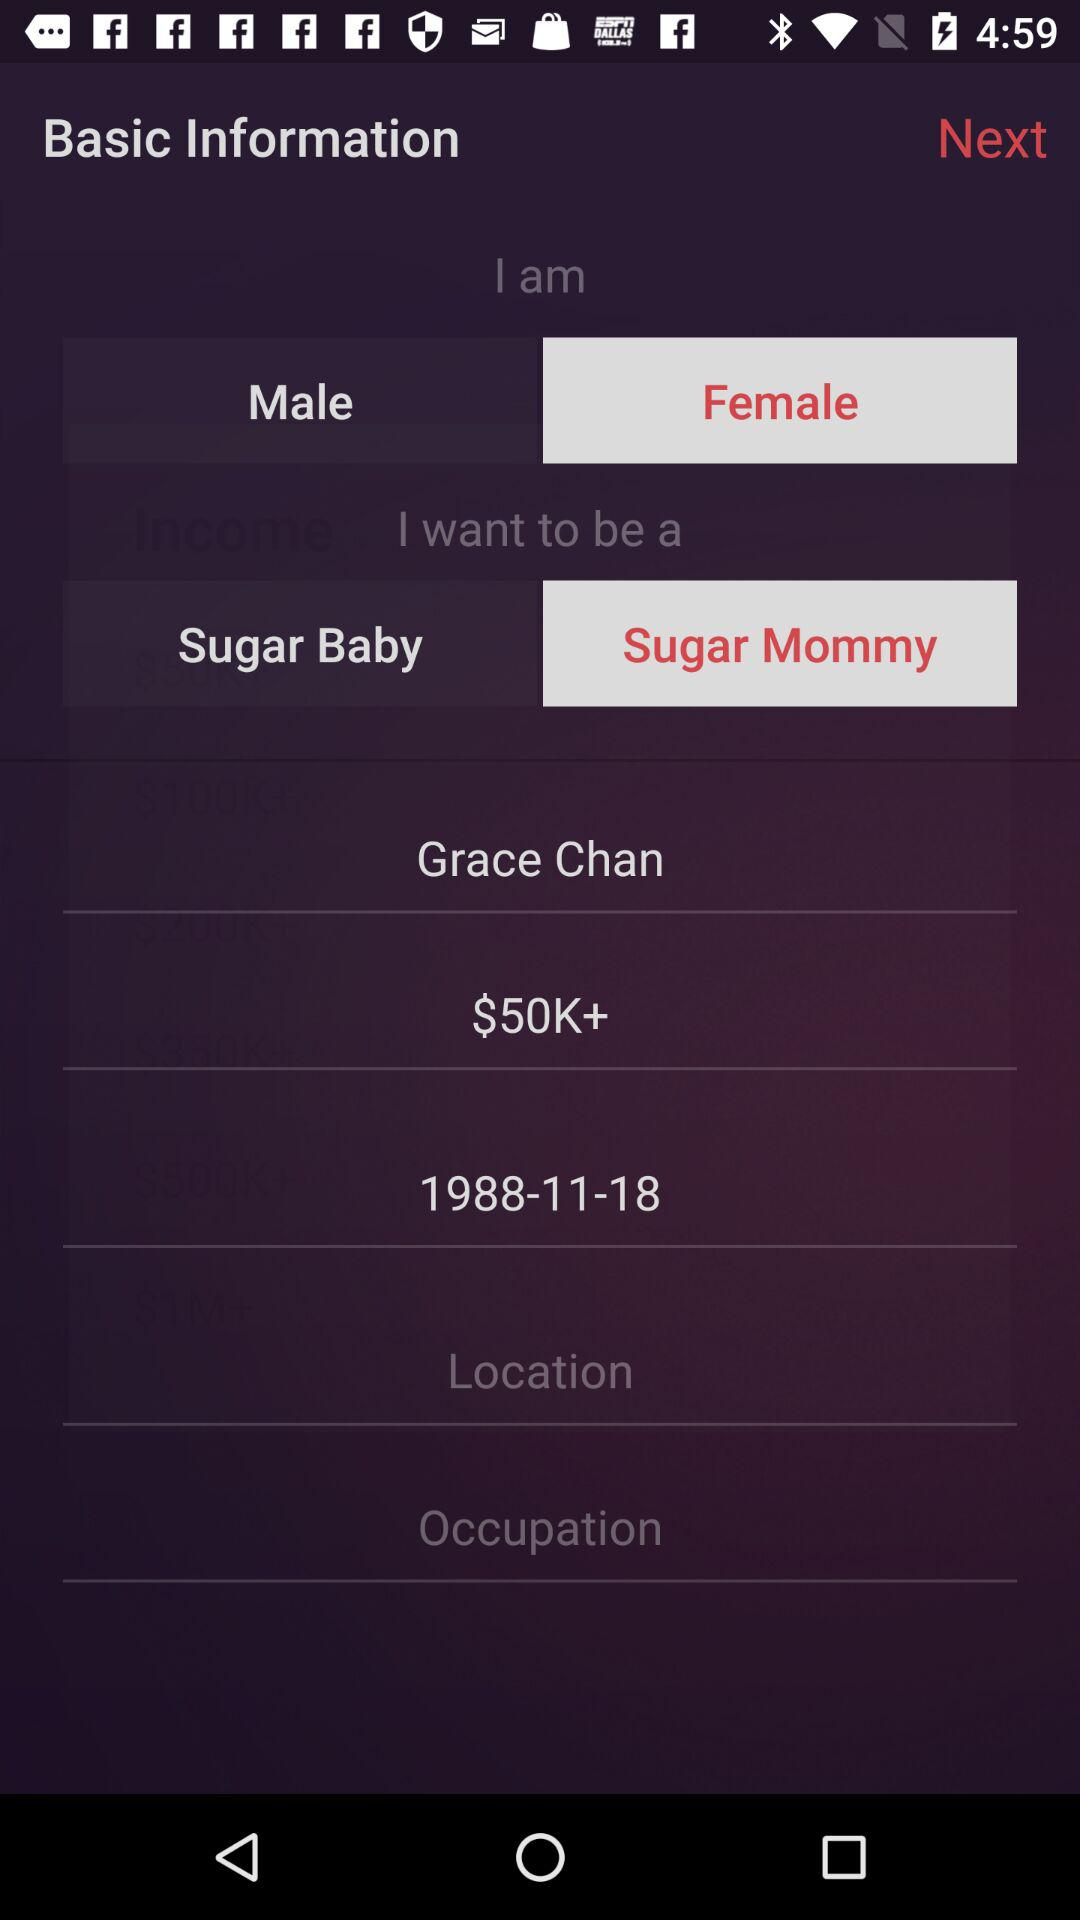How many options are available for the 'I want to be a' field?
Answer the question using a single word or phrase. 2 